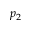Convert formula to latex. <formula><loc_0><loc_0><loc_500><loc_500>p _ { 2 }</formula> 